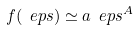Convert formula to latex. <formula><loc_0><loc_0><loc_500><loc_500>f ( \ e p s ) \simeq a \ e p s ^ { A }</formula> 